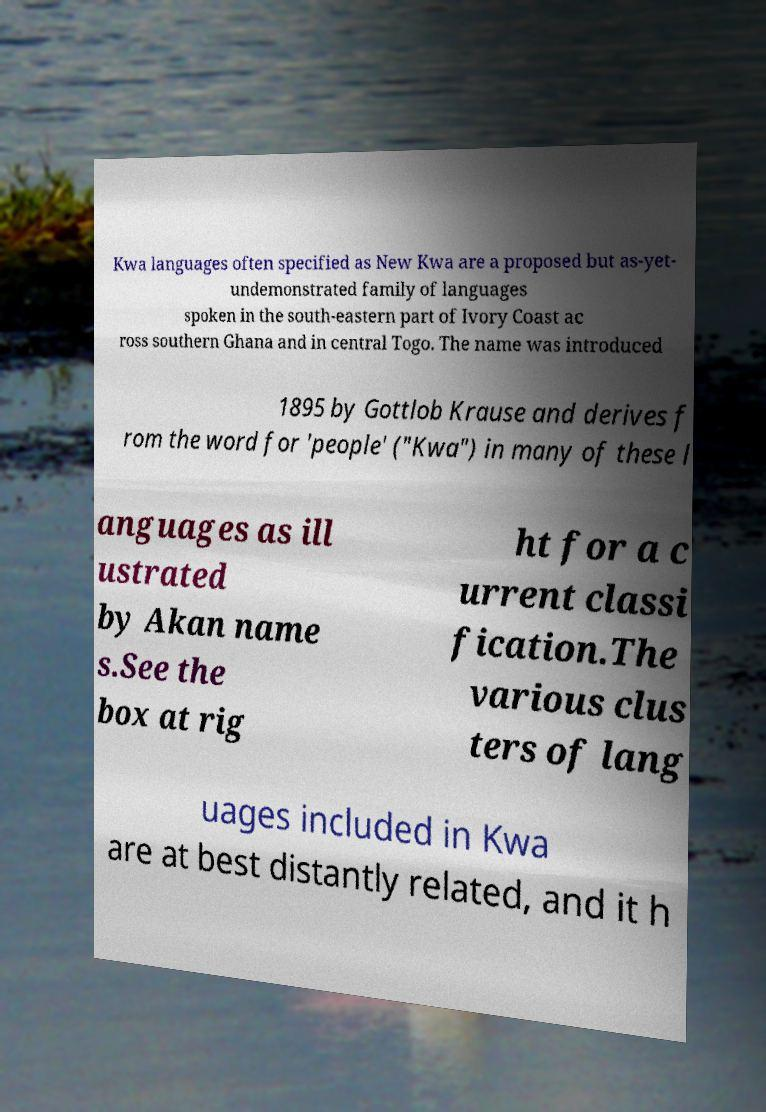Could you extract and type out the text from this image? Kwa languages often specified as New Kwa are a proposed but as-yet- undemonstrated family of languages spoken in the south-eastern part of Ivory Coast ac ross southern Ghana and in central Togo. The name was introduced 1895 by Gottlob Krause and derives f rom the word for 'people' ("Kwa") in many of these l anguages as ill ustrated by Akan name s.See the box at rig ht for a c urrent classi fication.The various clus ters of lang uages included in Kwa are at best distantly related, and it h 